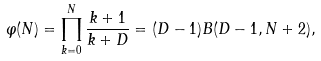Convert formula to latex. <formula><loc_0><loc_0><loc_500><loc_500>\varphi ( N ) = \prod _ { k = 0 } ^ { N } \frac { k + 1 } { k + D } = ( D - 1 ) B ( D - 1 , N + 2 ) ,</formula> 